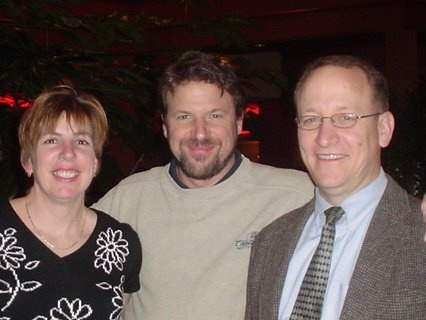Describe the objects in this image and their specific colors. I can see people in black, gray, lightpink, lavender, and darkgray tones, people in black, darkgray, gray, and tan tones, people in black, lightpink, darkgray, and gray tones, and tie in black, gray, and darkgray tones in this image. 